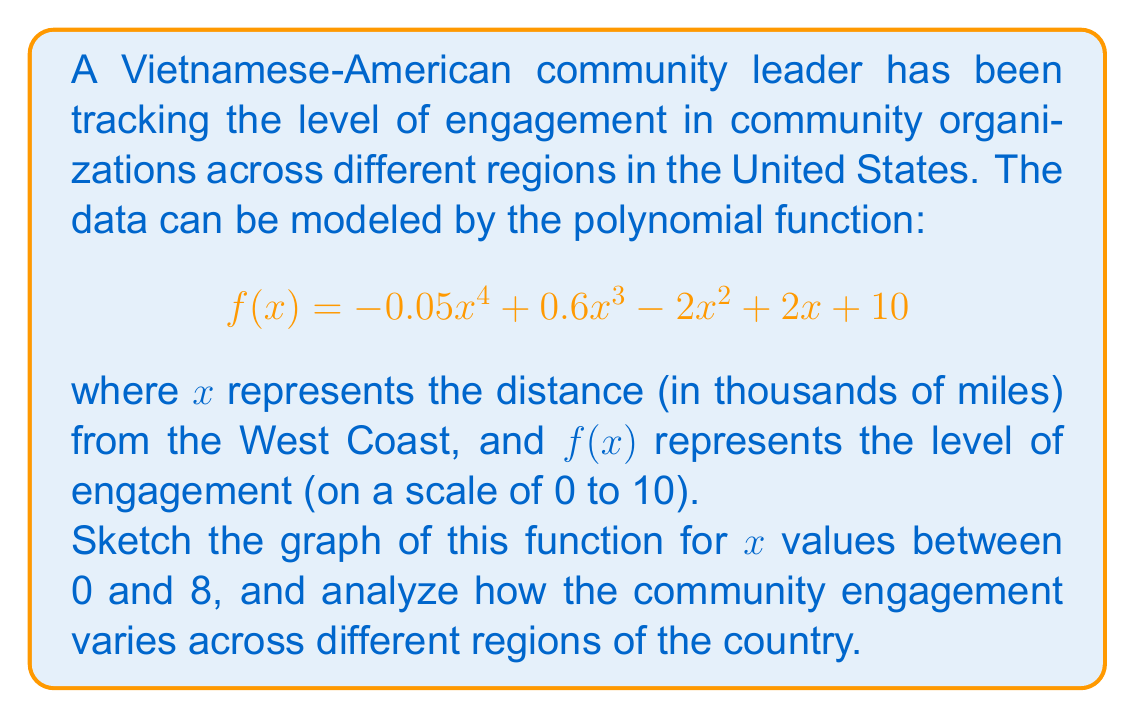Can you solve this math problem? To sketch the graph of this polynomial function, we'll follow these steps:

1) Identify the degree and leading coefficient:
   - Degree: 4 (highest power of x)
   - Leading coefficient: -0.05 (negative)

2) Find y-intercept:
   When $x = 0$, $f(0) = 10$

3) Find x-intercepts (if any):
   This is a 4th degree polynomial, so finding exact roots analytically is complex. We can estimate by looking at f(x) = 0 for integer values of x.

4) Find critical points:
   $f'(x) = -0.2x^3 + 1.8x^2 - 4x + 2$
   Setting $f'(x) = 0$ is complex, but we can estimate points where the slope changes.

5) Analyze end behavior:
   As $x \to \infty$, $f(x) \to -\infty$ (negative leading coefficient)
   As $x \to -\infty$, $f(x) \to -\infty$

6) Sketch the graph:

[asy]
import graph;
size(200,150);
real f(real x) {return -0.05*x^4 + 0.6*x^3 - 2*x^2 + 2*x + 10;}
draw(graph(f,0,8),blue);
xaxis("x (thousands of miles)",arrow=Arrow);
yaxis("f(x) (engagement level)",arrow=Arrow);
label("West Coast",(-0.5,0),W);
label("East Coast",(8,0),E);
[/asy]

Analysis:
- The engagement starts high on the West Coast (y-intercept at 10).
- It decreases as we move east, reaching a low point around 2-3 thousand miles from the West Coast (possibly representing the Midwest).
- There's a resurgence in engagement as we approach the East Coast, but it doesn't reach the same level as the West Coast.
- The engagement level starts to decrease again at the far East Coast.

This pattern could reflect the historical settlement patterns of Vietnamese-Americans, with larger communities on the coasts and smaller ones in the middle of the country.
Answer: The graph of $f(x) = -0.05x^4 + 0.6x^3 - 2x^2 + 2x + 10$ for $x$ between 0 and 8 is a curve that starts at (0,10), decreases to a minimum around x = 2-3, increases to a local maximum around x = 6-7, and then begins to decrease again. This represents high engagement on the West Coast, lower engagement in the Midwest, increased engagement on the East Coast, and a slight decline at the far East Coast. 